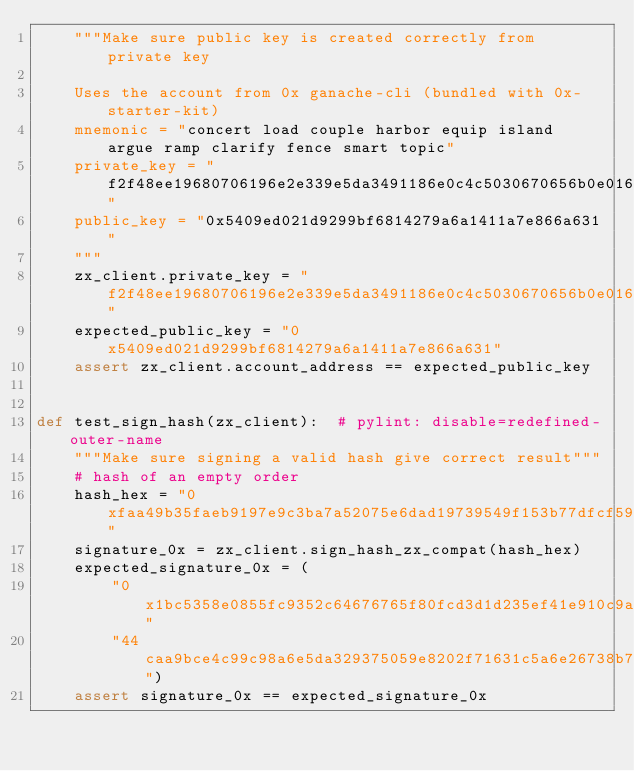Convert code to text. <code><loc_0><loc_0><loc_500><loc_500><_Python_>    """Make sure public key is created correctly from private key

    Uses the account from 0x ganache-cli (bundled with 0x-starter-kit)
    mnemonic = "concert load couple harbor equip island argue ramp clarify fence smart topic"
    private_key = "f2f48ee19680706196e2e339e5da3491186e0c4c5030670656b0e0164837257d"
    public_key = "0x5409ed021d9299bf6814279a6a1411a7e866a631"
    """
    zx_client.private_key = "f2f48ee19680706196e2e339e5da3491186e0c4c5030670656b0e0164837257d"
    expected_public_key = "0x5409ed021d9299bf6814279a6a1411a7e866a631"
    assert zx_client.account_address == expected_public_key


def test_sign_hash(zx_client):  # pylint: disable=redefined-outer-name
    """Make sure signing a valid hash give correct result"""
    # hash of an empty order
    hash_hex = "0xfaa49b35faeb9197e9c3ba7a52075e6dad19739549f153b77dfcf59408a4b422"
    signature_0x = zx_client.sign_hash_zx_compat(hash_hex)
    expected_signature_0x = (
        "0x1bc5358e0855fc9352c64676765f80fcd3d1d235ef41e910c9a59b22fcbd573e5"
        "44caa9bce4c99c98a6e5da329375059e8202f71631c5a6e26738b79817161c9ac03")
    assert signature_0x == expected_signature_0x
</code> 